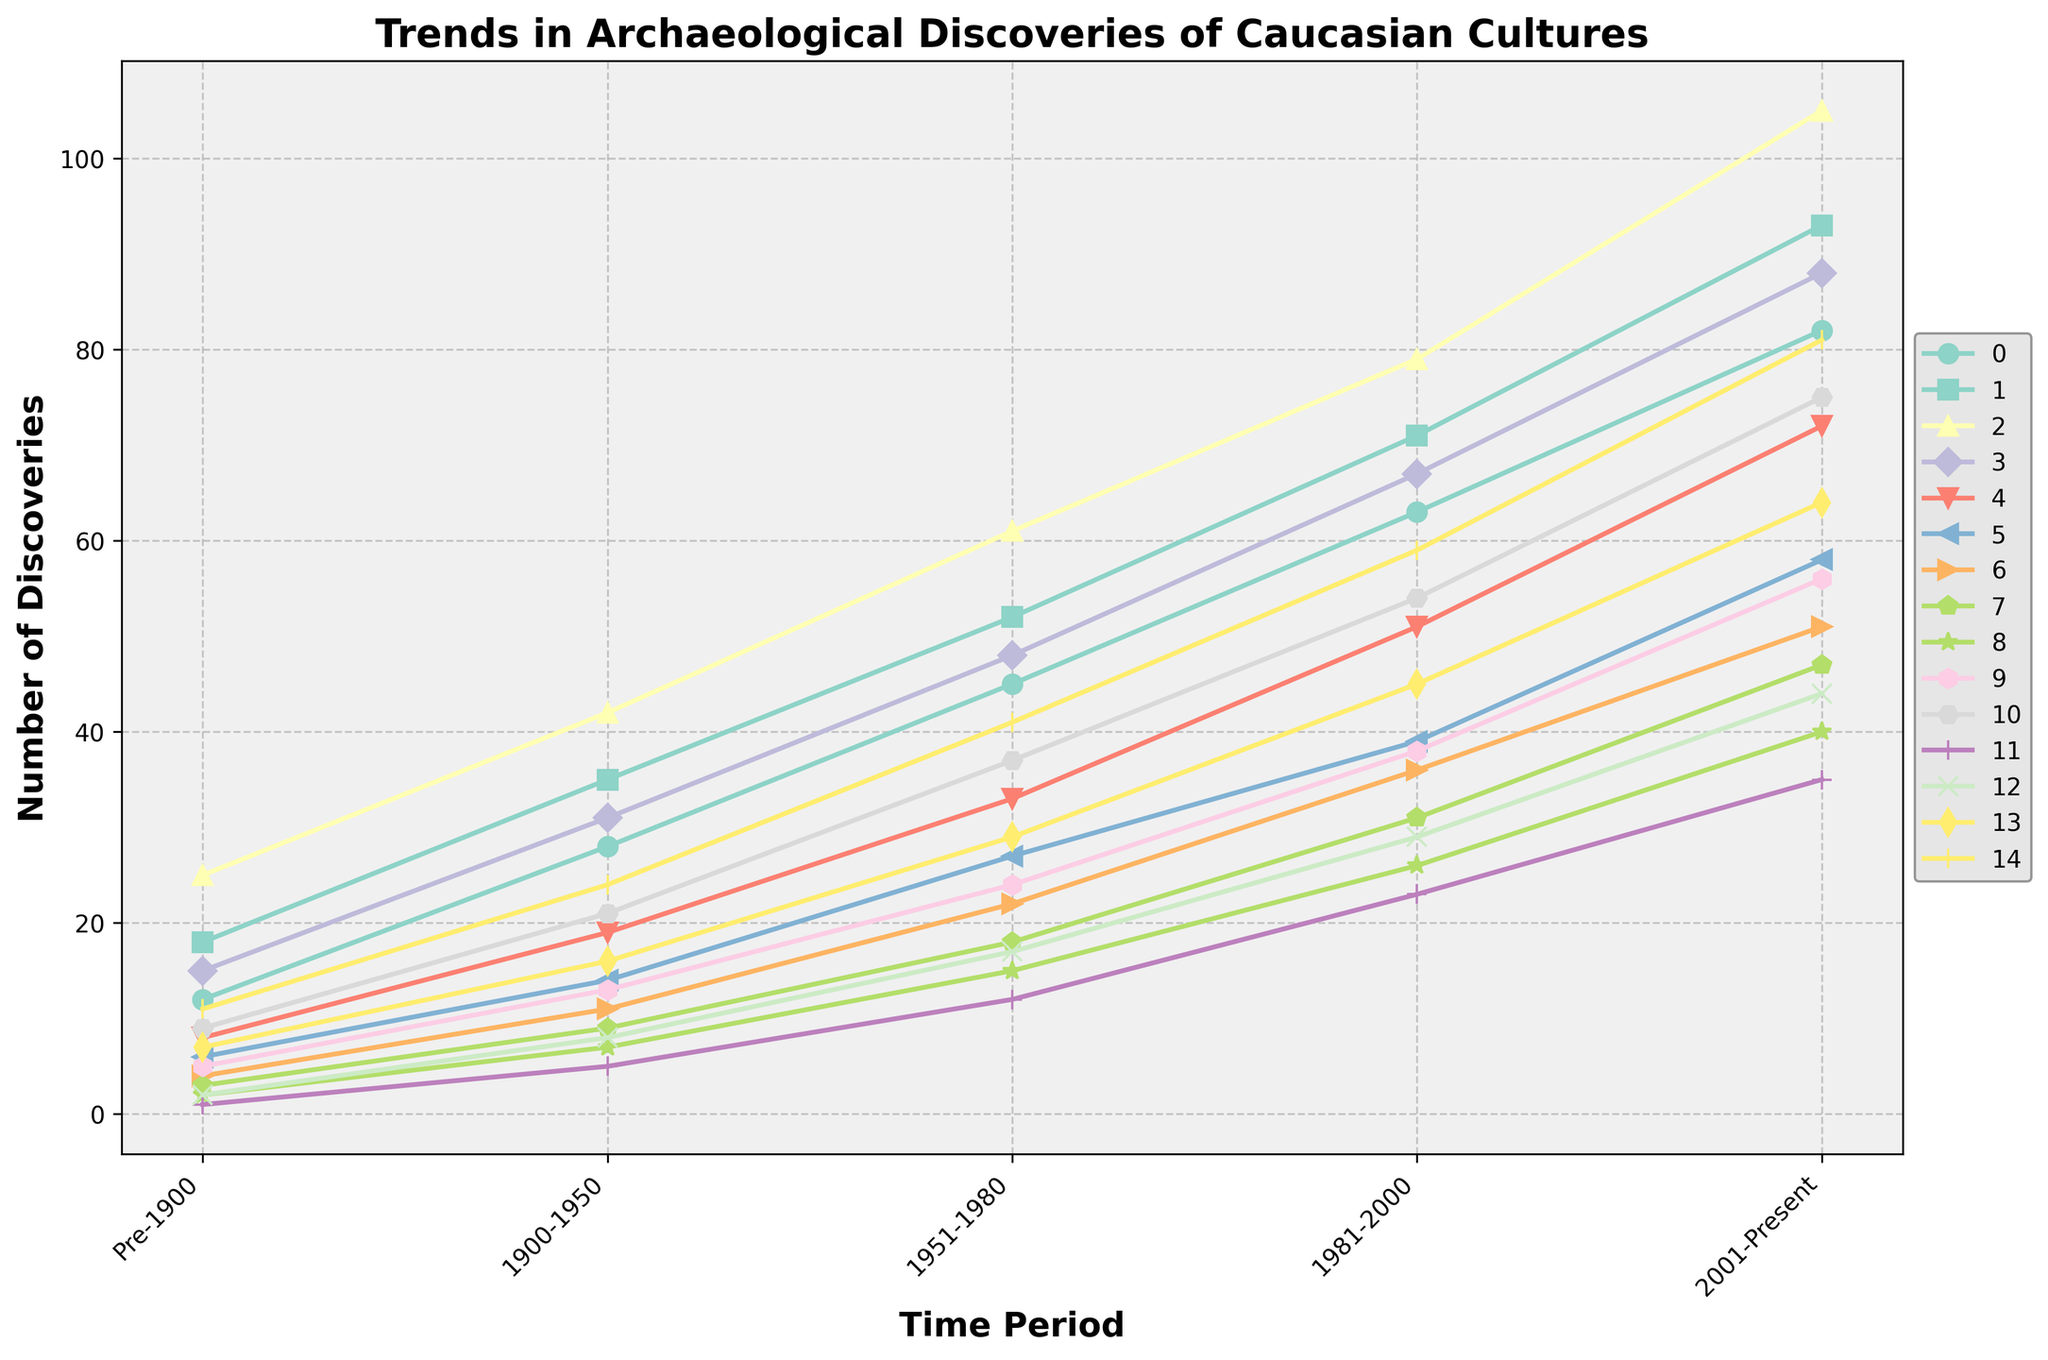What historical period saw the greatest increase in archaeological discoveries from Pre-1900 to 2001-Present? To find the greatest increase, we need to calculate the difference between the values for Pre-1900 and 2001-Present for each period. The period with the largest difference is the Classical Antiquity, which increased from 25 to 105, a difference of 80.
Answer: Classical Antiquity Which two periods have the closest number of archaeological discoveries in the 1981-2000 period? By examining the data for the 1981-2000 period, we see the closest numbers are for the Scythian (39) and Early Modern (51) periods, which differ by 12.
Answer: Scythian and Early Modern During the 2001-Present period, which cultures had fewer than 50 archaeological discoveries? By inspecting the 2001-Present period data, only the Alanian (47), Caucasian Albania (40), Khazar Khaganate (35), and Golden Horde (44) have fewer than 50 discoveries.
Answer: Alanian, Caucasian Albania, Khazar Khaganate, Golden Horde Which period has shown the most consistent trend in archaeological discoveries over the past 150 years? A consistent trend implies steady increases without large fluctuations. The Iron Age period shows a steady increase: 18, 35, 52, 71, and 93.
Answer: Iron Age What is the average number of archaeological discoveries for the Early Modern period across all time periods? Sum the discoveries for Early Modern: 8, 19, 33, 51, 72, which totals 183. Then divide by the number of periods (5) to get the average: 183/5 = 36.6.
Answer: 36.6 Between the Ottoman Empire and the Russian Empire from 1900-1950, which had more discoveries and by how much? For 1900-1950, the Ottoman Empire had 16 and the Russian Empire had 24. The difference is 24 - 16 = 8. Therefore, the Russian Empire had 8 more discoveries.
Answer: Russian Empire by 8 Which cultures saw the highest increase in discoveries from 1981-2000 to 2001-Present? Calculate the difference for each period: Classical Antiquity (105-79=26), Iron Age (93-71=22), etc. The highest increase is in the Classical Antiquity with 26.
Answer: Classical Antiquity Among the periods captured, which had the least number of discoveries in Pre-1900 and what was the count? By examining the Pre-1900 data, the Khazar Khaganate had the least discoveries with a count of 1.
Answer: Khazar Khaganate, 1 What is the total number of Bronze Age discoveries over all periods? Sum all the data points for the Bronze Age: 12, 28, 45, 63, 82, resulting in 230 discoveries.
Answer: 230 Are there any time periods where Medieval discoveries exceeded 60? By inspecting the chart, the Medieval period exceeds 60 discoveries in 1981-2000 (67) and 2001-Present (88).
Answer: Yes, 1981-2000 and 2001-Present 